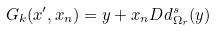<formula> <loc_0><loc_0><loc_500><loc_500>G _ { k } ( x ^ { \prime } , x _ { n } ) = y + x _ { n } D d ^ { s } _ { \Omega _ { r } } ( y )</formula> 